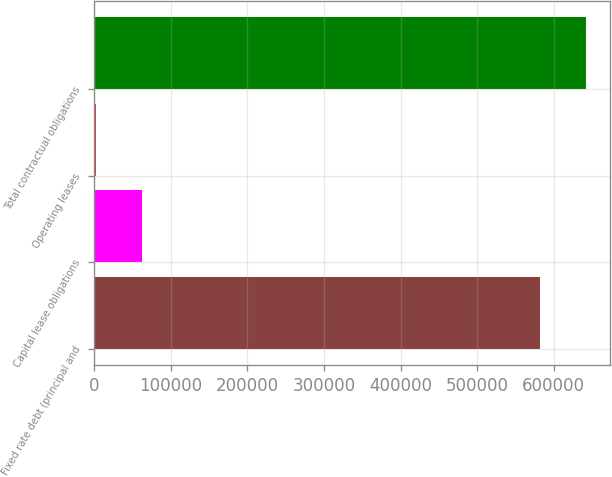<chart> <loc_0><loc_0><loc_500><loc_500><bar_chart><fcel>Fixed rate debt (principal and<fcel>Capital lease obligations<fcel>Operating leases<fcel>Total contractual obligations<nl><fcel>581791<fcel>62302.8<fcel>2620<fcel>641474<nl></chart> 